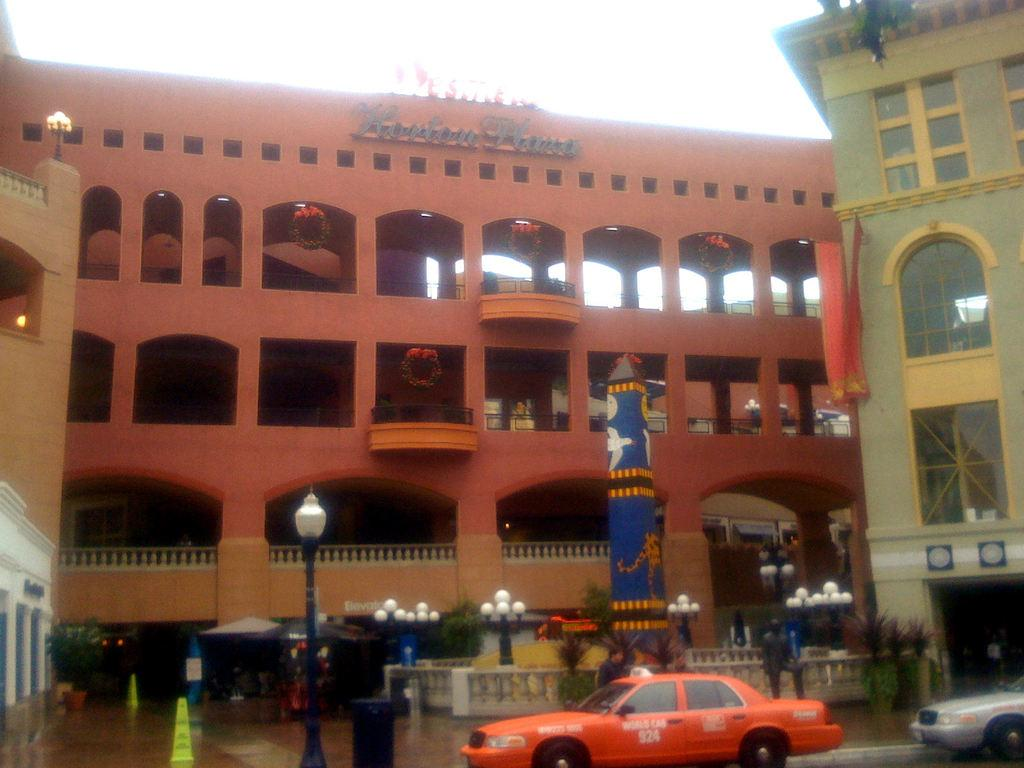<image>
Describe the image concisely. An orange WORLD CAB number 924 sits in front of a building. 